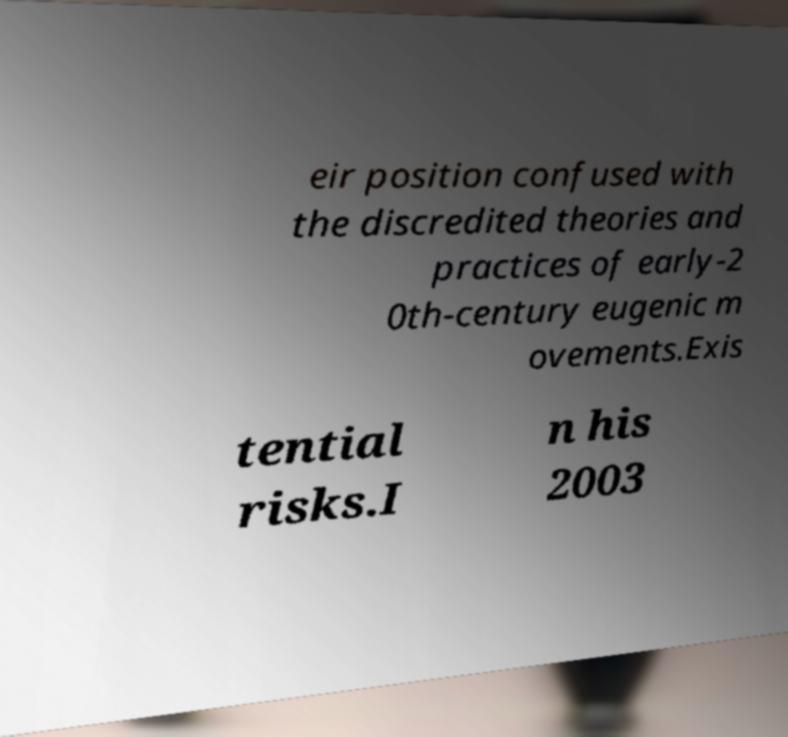Could you assist in decoding the text presented in this image and type it out clearly? eir position confused with the discredited theories and practices of early-2 0th-century eugenic m ovements.Exis tential risks.I n his 2003 